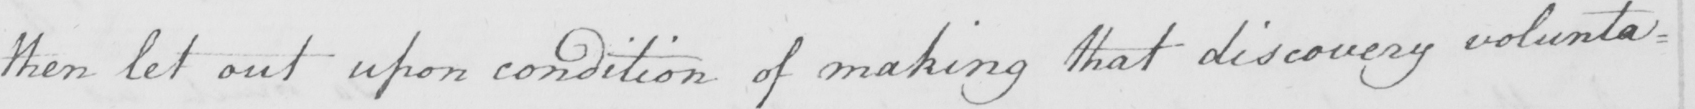Please provide the text content of this handwritten line. then let out upon condition of making that discovery volunta= 